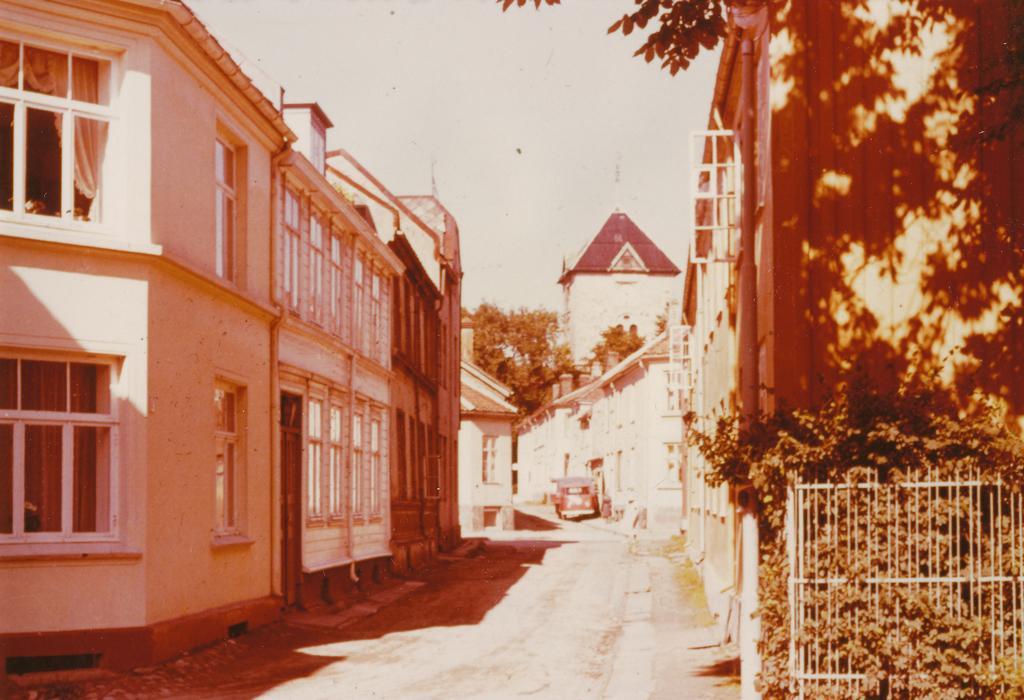Can you describe this image briefly? In this picture we can see buildings, fence, plants, and trees. There is a car on the road. In the background we can see sky. 